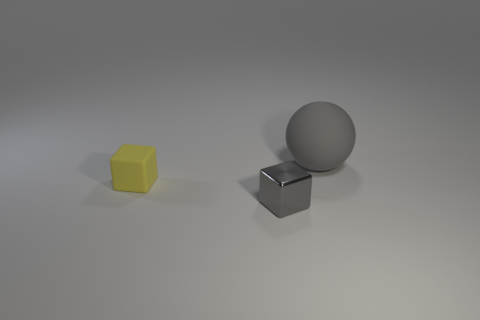What number of small objects are either rubber balls or red blocks?
Ensure brevity in your answer.  0. What is the color of the block that is the same size as the metal object?
Your response must be concise. Yellow. What number of gray rubber spheres are behind the small matte thing?
Give a very brief answer. 1. Is there a gray ball that has the same material as the yellow cube?
Your response must be concise. Yes. What shape is the other object that is the same color as the big matte object?
Offer a terse response. Cube. There is a rubber thing that is on the left side of the gray block; what color is it?
Offer a terse response. Yellow. Is the number of gray objects behind the matte sphere the same as the number of gray metal objects that are in front of the tiny gray cube?
Your response must be concise. Yes. The object that is to the right of the block in front of the small rubber block is made of what material?
Offer a terse response. Rubber. What number of objects are gray blocks or gray objects that are to the left of the ball?
Your answer should be compact. 1. What size is the object that is made of the same material as the large gray ball?
Ensure brevity in your answer.  Small. 